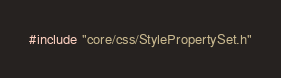<code> <loc_0><loc_0><loc_500><loc_500><_C++_>#include "core/css/StylePropertySet.h"</code> 